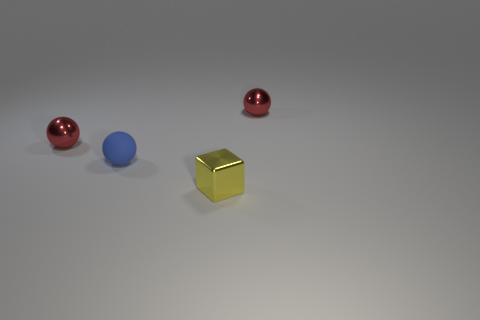Add 3 balls. How many objects exist? 7 Subtract all spheres. How many objects are left? 1 Add 1 tiny metal objects. How many tiny metal objects exist? 4 Subtract 0 gray balls. How many objects are left? 4 Subtract all tiny red objects. Subtract all yellow objects. How many objects are left? 1 Add 4 spheres. How many spheres are left? 7 